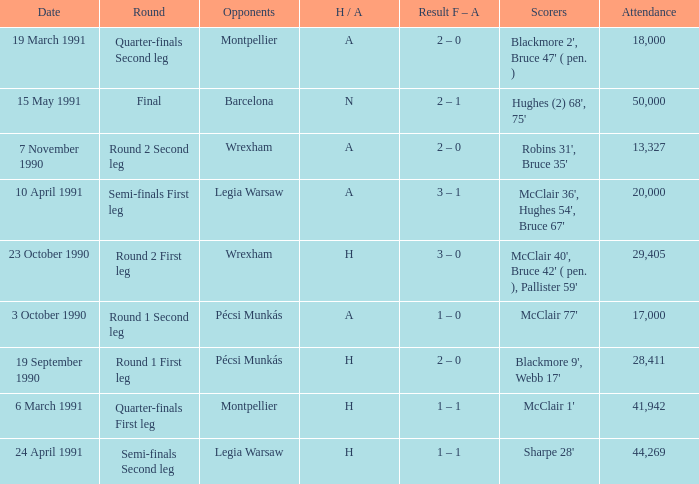Can you give me this table as a dict? {'header': ['Date', 'Round', 'Opponents', 'H / A', 'Result F – A', 'Scorers', 'Attendance'], 'rows': [['19 March 1991', 'Quarter-finals Second leg', 'Montpellier', 'A', '2 – 0', "Blackmore 2', Bruce 47' ( pen. )", '18,000'], ['15 May 1991', 'Final', 'Barcelona', 'N', '2 – 1', "Hughes (2) 68', 75'", '50,000'], ['7 November 1990', 'Round 2 Second leg', 'Wrexham', 'A', '2 – 0', "Robins 31', Bruce 35'", '13,327'], ['10 April 1991', 'Semi-finals First leg', 'Legia Warsaw', 'A', '3 – 1', "McClair 36', Hughes 54', Bruce 67'", '20,000'], ['23 October 1990', 'Round 2 First leg', 'Wrexham', 'H', '3 – 0', "McClair 40', Bruce 42' ( pen. ), Pallister 59'", '29,405'], ['3 October 1990', 'Round 1 Second leg', 'Pécsi Munkás', 'A', '1 – 0', "McClair 77'", '17,000'], ['19 September 1990', 'Round 1 First leg', 'Pécsi Munkás', 'H', '2 – 0', "Blackmore 9', Webb 17'", '28,411'], ['6 March 1991', 'Quarter-finals First leg', 'Montpellier', 'H', '1 – 1', "McClair 1'", '41,942'], ['24 April 1991', 'Semi-finals Second leg', 'Legia Warsaw', 'H', '1 – 1', "Sharpe 28'", '44,269']]} What is the lowest attendance when the h/A is H in the Semi-Finals Second Leg? 44269.0. 